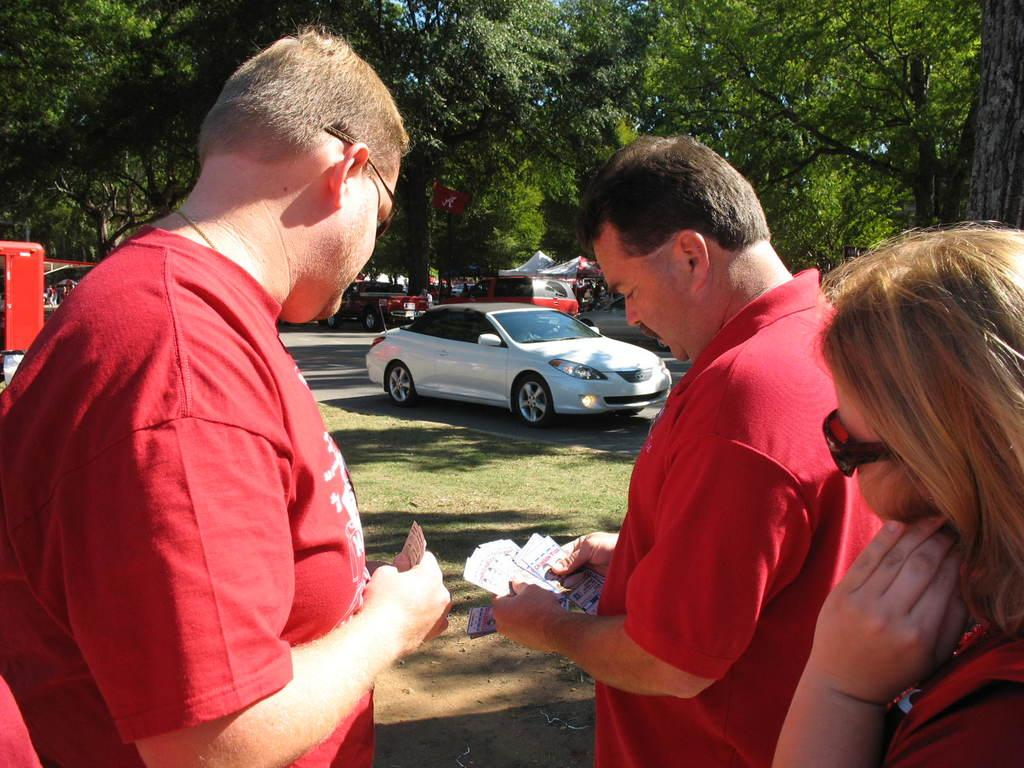What can be seen in the image? There is a group of people in the image. What are the people wearing? The people are wearing red-colored dresses. What else is present in the image besides the people? There are trees in the image. Can you describe the setting or environment in the image? There is a car traveling on the road in the image, which suggests an outdoor or street setting. What type of picture is hanging on the wall in the image? There is no mention of a picture hanging on the wall in the image; the focus is on the group of people, their clothing, the trees, and the car on the road. 